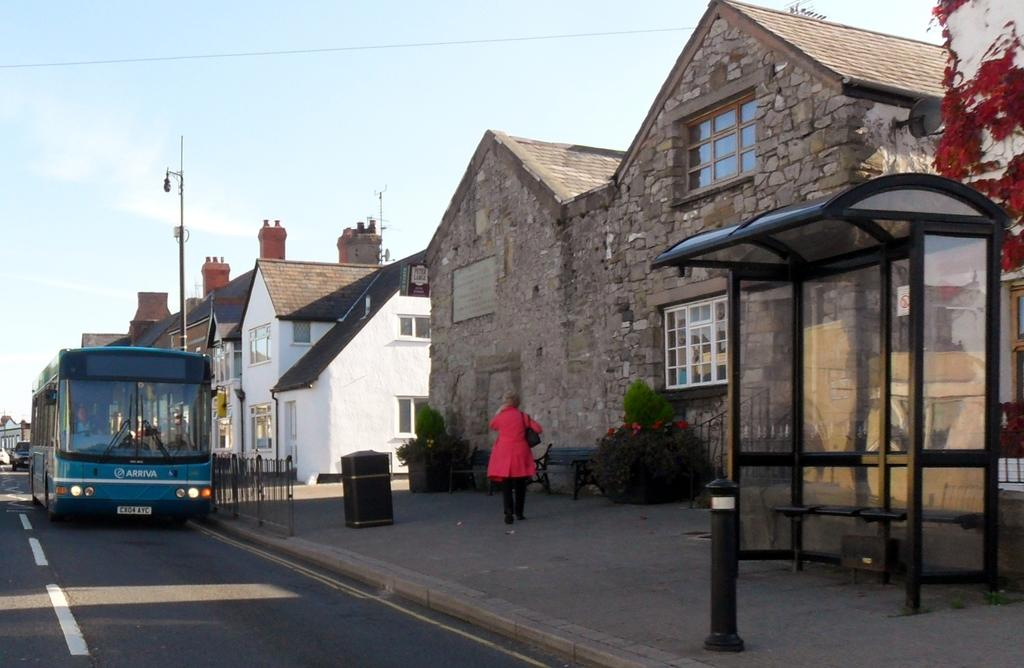What is located on the left side of the image? There is a bus on the left side of the image. Where is the bus situated? The bus is on the road. What can be seen in the middle of the image? There is a person walking in the middle of the image. What is the person wearing? The person is wearing a pink coat. What type of structures are visible in the image? There are houses in the image. What is visible at the top of the image? The sky is visible at the top of the image. Can you tell me how much sugar is in the lake in the image? There is no lake present in the image, so it is not possible to determine the amount of sugar in it. How many passengers are on the bus in the image? The number of passengers on the bus cannot be determined from the image, as we cannot see inside the bus. 